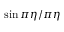<formula> <loc_0><loc_0><loc_500><loc_500>\sin \pi \eta / \pi \eta</formula> 